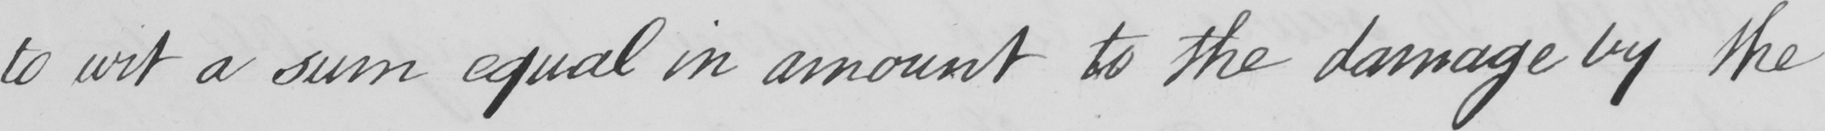Can you read and transcribe this handwriting? to wit a sum equal in amount to the damage by the 